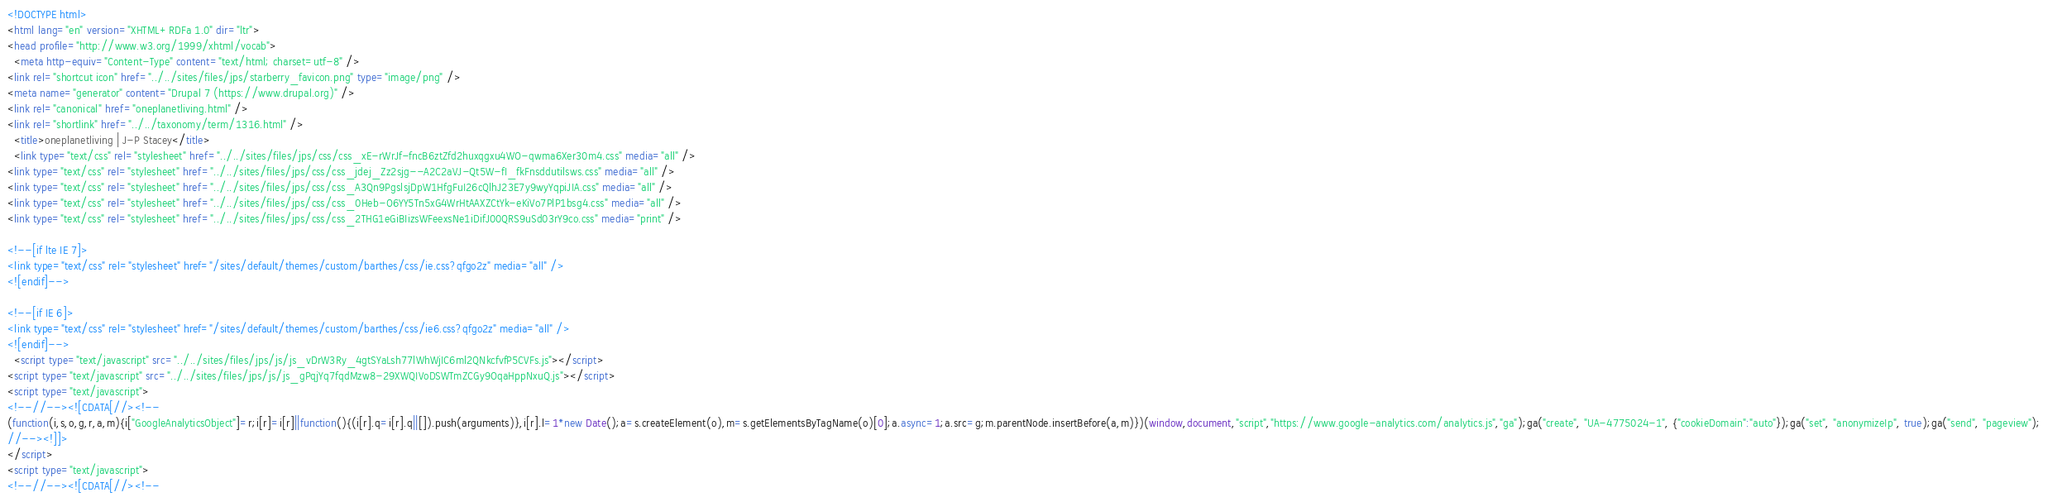<code> <loc_0><loc_0><loc_500><loc_500><_HTML_><!DOCTYPE html>
<html lang="en" version="XHTML+RDFa 1.0" dir="ltr">
<head profile="http://www.w3.org/1999/xhtml/vocab">
  <meta http-equiv="Content-Type" content="text/html; charset=utf-8" />
<link rel="shortcut icon" href="../../sites/files/jps/starberry_favicon.png" type="image/png" />
<meta name="generator" content="Drupal 7 (https://www.drupal.org)" />
<link rel="canonical" href="oneplanetliving.html" />
<link rel="shortlink" href="../../taxonomy/term/1316.html" />
  <title>oneplanetliving | J-P Stacey</title>
  <link type="text/css" rel="stylesheet" href="../../sites/files/jps/css/css_xE-rWrJf-fncB6ztZfd2huxqgxu4WO-qwma6Xer30m4.css" media="all" />
<link type="text/css" rel="stylesheet" href="../../sites/files/jps/css/css_jdej_Zz2sjg--A2C2aVJ-Qt5W-fI_fkFnsddutilsws.css" media="all" />
<link type="text/css" rel="stylesheet" href="../../sites/files/jps/css/css_A3Qn9PgslsjDpW1HfgFuI26cQlhJ23E7y9wyYqpiJIA.css" media="all" />
<link type="text/css" rel="stylesheet" href="../../sites/files/jps/css/css_0Heb-O6YY5Tn5xG4WrHtAAXZCtYk-eKiVo7PlP1bsg4.css" media="all" />
<link type="text/css" rel="stylesheet" href="../../sites/files/jps/css/css_2THG1eGiBIizsWFeexsNe1iDifJ00QRS9uSd03rY9co.css" media="print" />

<!--[if lte IE 7]>
<link type="text/css" rel="stylesheet" href="/sites/default/themes/custom/barthes/css/ie.css?qfgo2z" media="all" />
<![endif]-->

<!--[if IE 6]>
<link type="text/css" rel="stylesheet" href="/sites/default/themes/custom/barthes/css/ie6.css?qfgo2z" media="all" />
<![endif]-->
  <script type="text/javascript" src="../../sites/files/jps/js/js_vDrW3Ry_4gtSYaLsh77lWhWjIC6ml2QNkcfvfP5CVFs.js"></script>
<script type="text/javascript" src="../../sites/files/jps/js/js_gPqjYq7fqdMzw8-29XWQIVoDSWTmZCGy9OqaHppNxuQ.js"></script>
<script type="text/javascript">
<!--//--><![CDATA[//><!--
(function(i,s,o,g,r,a,m){i["GoogleAnalyticsObject"]=r;i[r]=i[r]||function(){(i[r].q=i[r].q||[]).push(arguments)},i[r].l=1*new Date();a=s.createElement(o),m=s.getElementsByTagName(o)[0];a.async=1;a.src=g;m.parentNode.insertBefore(a,m)})(window,document,"script","https://www.google-analytics.com/analytics.js","ga");ga("create", "UA-4775024-1", {"cookieDomain":"auto"});ga("set", "anonymizeIp", true);ga("send", "pageview");
//--><!]]>
</script>
<script type="text/javascript">
<!--//--><![CDATA[//><!--</code> 